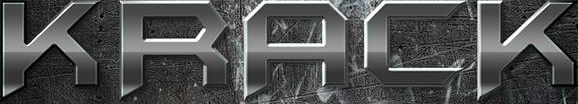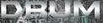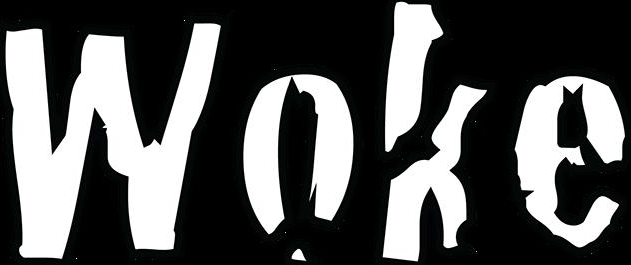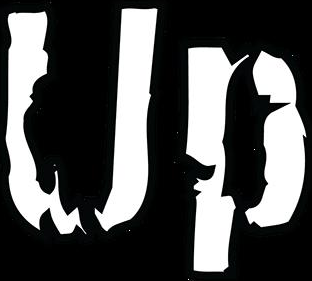Read the text content from these images in order, separated by a semicolon. KRACK; DRUM; Woke; Up 